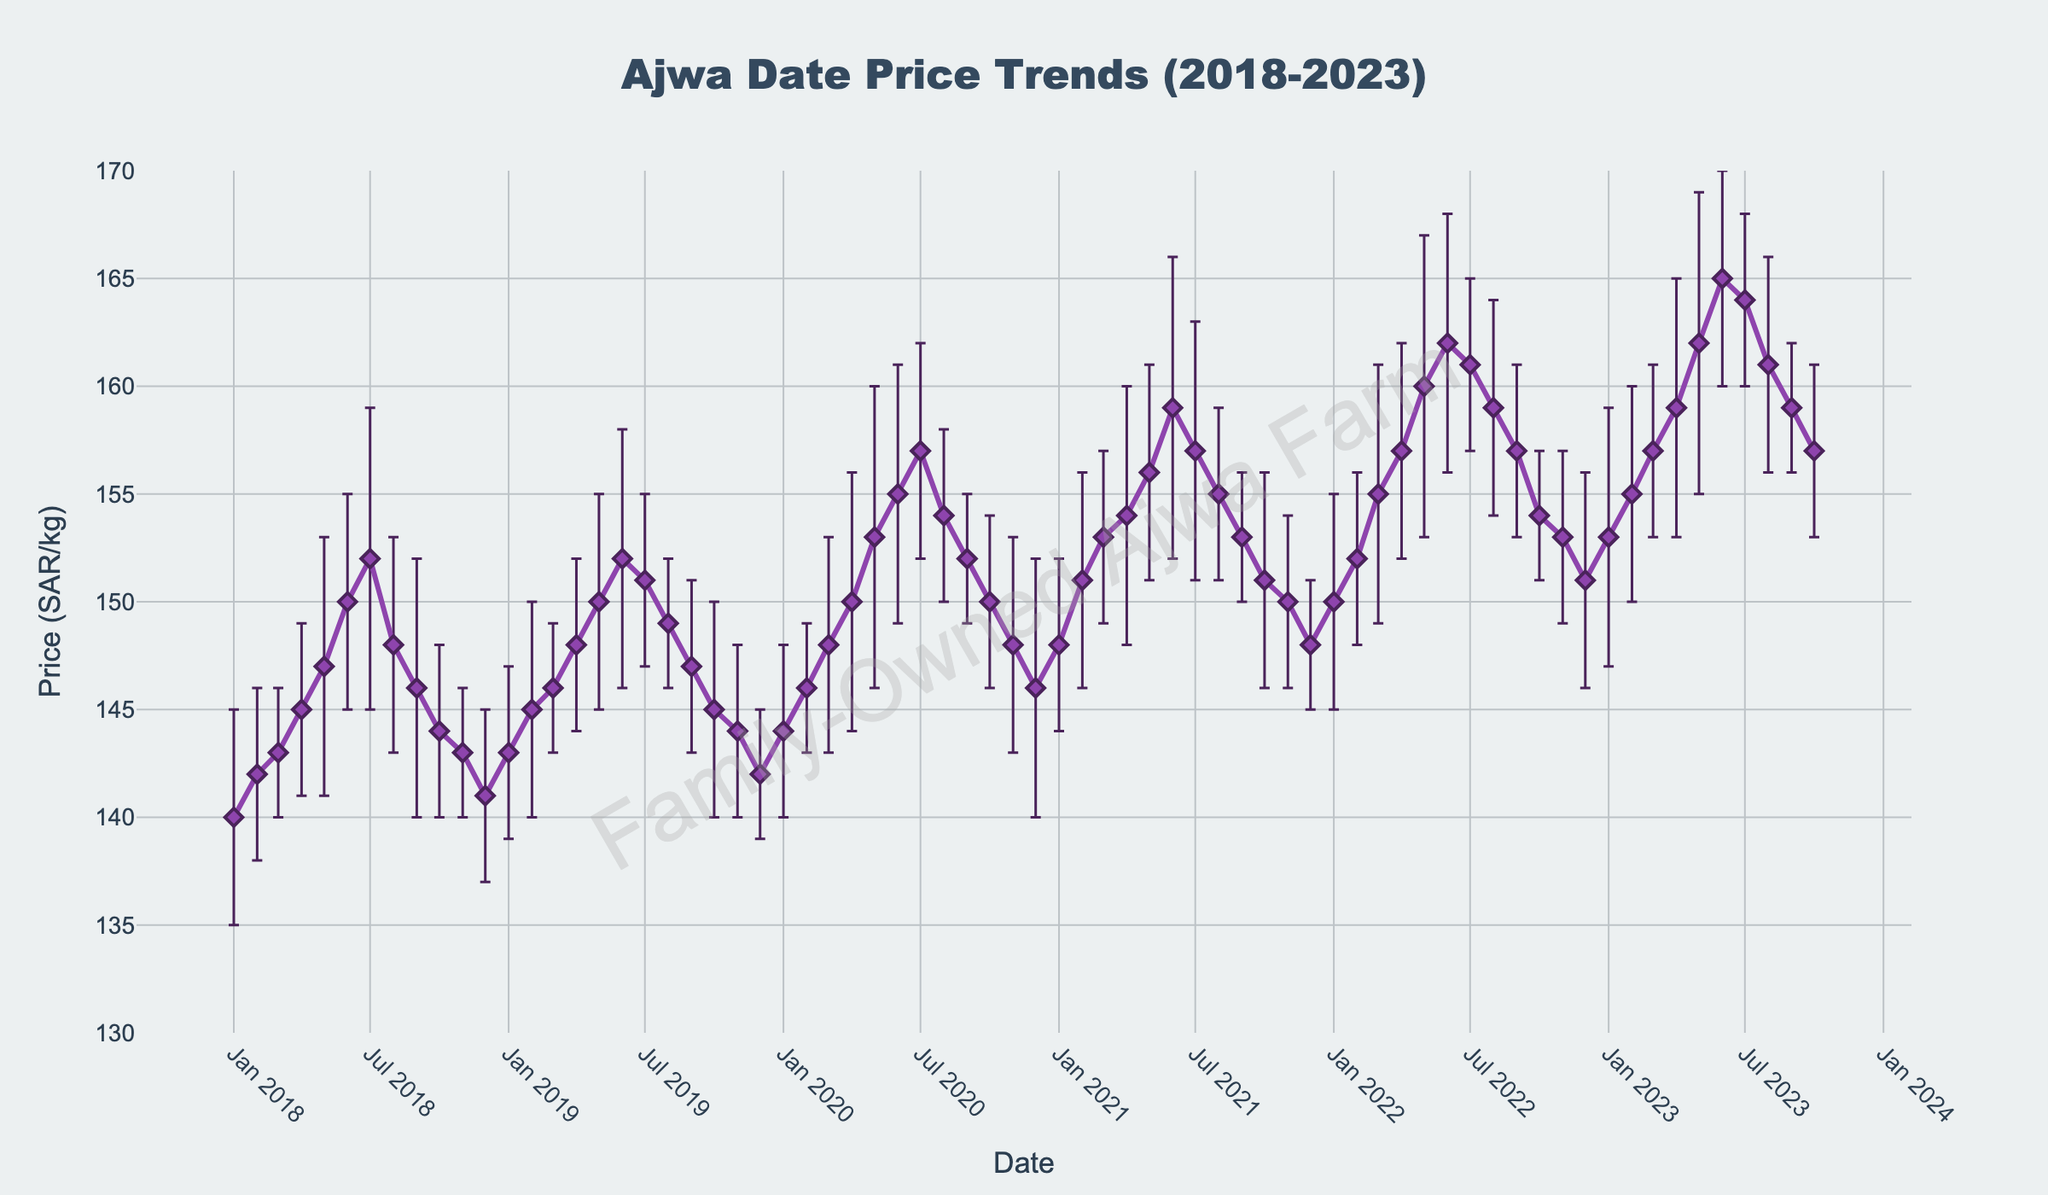What is the title of the plot? The title of the plot is typically located at the top of the figure. In this case, the title is clearly written.
Answer: Ajwa Date Price Trends (2018-2023) What are the x and y axes labels? The labels for the axes are usually found right below the x-axis and right beside the y-axis. Here, the x-axis is labeled 'Date' and the y-axis is labeled 'Price (SAR/kg)'.
Answer: Date and Price (SAR/kg) How does the price of Ajwa dates change from January 2018 to January 2023? To determine this, one must examine the plot's trend between these two dates. The price in January 2018 is 140 SAR/kg, while in January 2023, it is 153 SAR/kg. The trend shows a rising pattern over these years.
Answer: It increased from 140 to 153 SAR/kg What is the month with the highest price of Ajwa dates in the dataset? By scanning the plot for the highest point, it is noticeable that the highest price occurred in June 2023, where the price peaked at 165 SAR/kg.
Answer: June 2023 During which year did the price of Ajwa dates seem to remain relatively stable with lower volatility? By observing the error bars on the plot, shorter error bars indicate lower volatility. In the year 2019, the error bars are generally shorter, indicating lower volatility.
Answer: 2019 Which year experienced the highest increase in the average price of Ajwa dates compared to the prior year? To determine this, we compare the average prices year by year. The biggest jump can be seen from 2021 to 2022 where the price increased from 148 SAR/kg in December 2021 to 150 SAR/kg in January 2022, continuing to rise throughout the year.
Answer: 2022 How often do the average prices of Ajwa dates experience a decrease in monthly volatility? By tracking the length of error bars month by month, decreases in volatility can be observed. For example, from May 2023 to June 2023, the volatility reduces from 7 SAR/kg to 5 SAR/kg. Counting instances of such declines can provide an answer.
Answer: Multiple instances throughout, specific counts may vary Compare the price trends of January and July across each year from 2018 to 2023. Which month shows a more consistent price increase? By pinpointing January and July prices for each year, January prices show a steadier upward trend (140 to 153 SAR/kg) than July (152 to 164 SAR/kg), with less variability month-to-month.
Answer: January Which month and year combination shows the highest volatility? Volatility is represented by the size of the error bars. The highest error bar appears in June 2023 with a volatility of 7 SAR/kg.
Answer: June 2023 